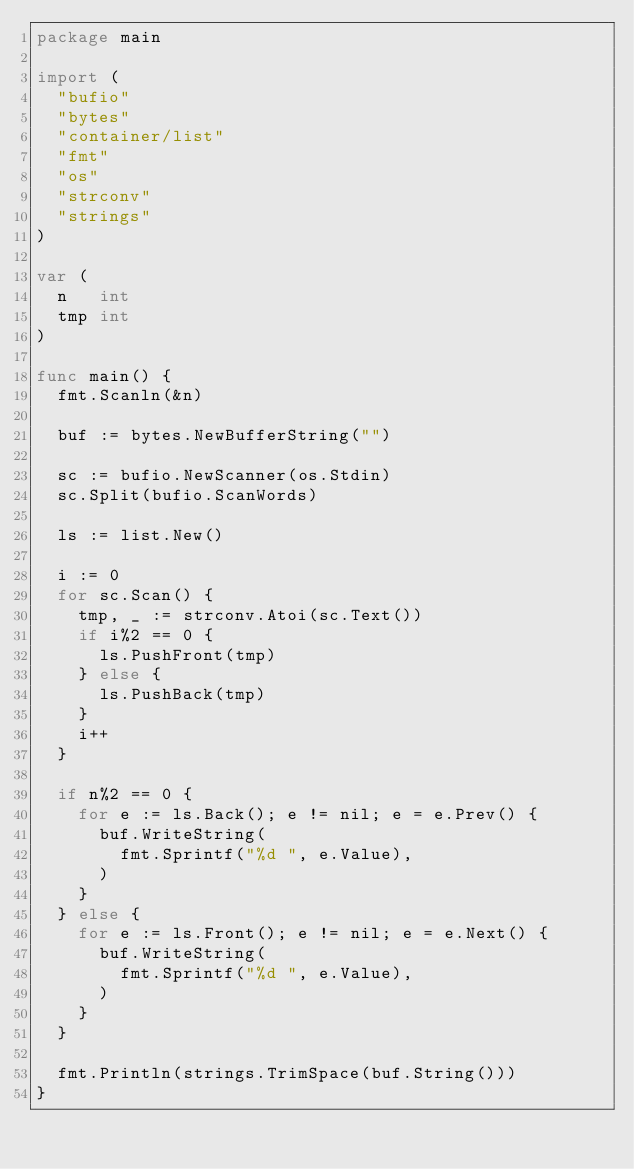<code> <loc_0><loc_0><loc_500><loc_500><_Go_>package main

import (
	"bufio"
	"bytes"
	"container/list"
	"fmt"
	"os"
	"strconv"
	"strings"
)

var (
	n   int
	tmp int
)

func main() {
	fmt.Scanln(&n)

	buf := bytes.NewBufferString("")

	sc := bufio.NewScanner(os.Stdin)
	sc.Split(bufio.ScanWords)

	ls := list.New()

	i := 0
	for sc.Scan() {
		tmp, _ := strconv.Atoi(sc.Text())
		if i%2 == 0 {
			ls.PushFront(tmp)
		} else {
			ls.PushBack(tmp)
		}
		i++
	}

	if n%2 == 0 {
		for e := ls.Back(); e != nil; e = e.Prev() {
			buf.WriteString(
				fmt.Sprintf("%d ", e.Value),
			)
		}
	} else {
		for e := ls.Front(); e != nil; e = e.Next() {
			buf.WriteString(
				fmt.Sprintf("%d ", e.Value),
			)
		}
	}

	fmt.Println(strings.TrimSpace(buf.String()))
}</code> 